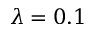<formula> <loc_0><loc_0><loc_500><loc_500>\lambda = 0 . 1</formula> 